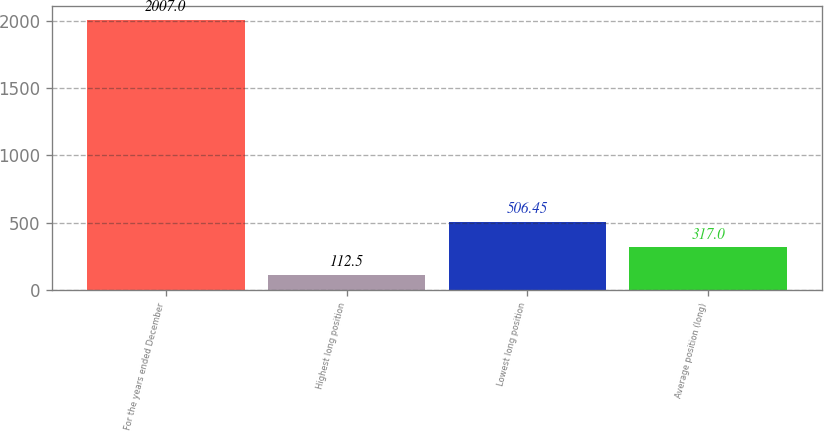Convert chart to OTSL. <chart><loc_0><loc_0><loc_500><loc_500><bar_chart><fcel>For the years ended December<fcel>Highest long position<fcel>Lowest long position<fcel>Average position (long)<nl><fcel>2007<fcel>112.5<fcel>506.45<fcel>317<nl></chart> 